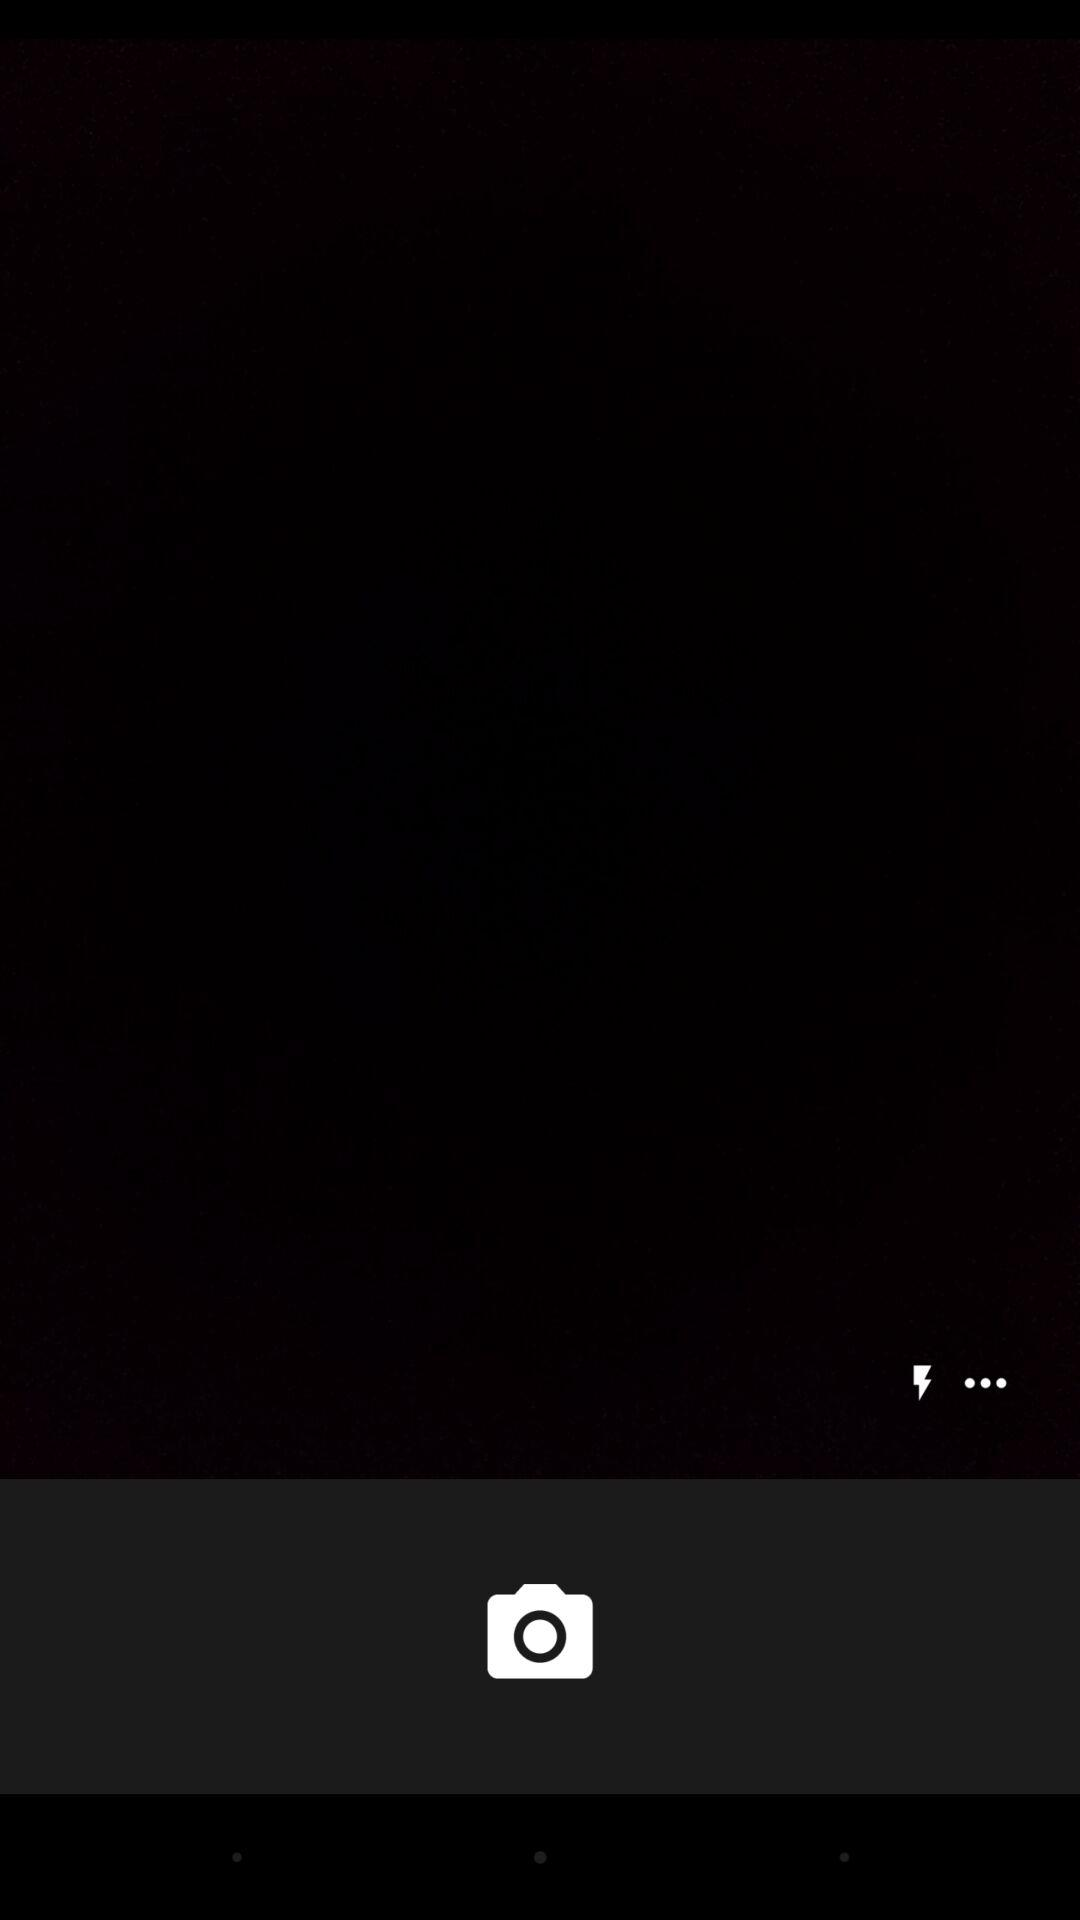How many more white dots are there than lightning bolts?
Answer the question using a single word or phrase. 2 